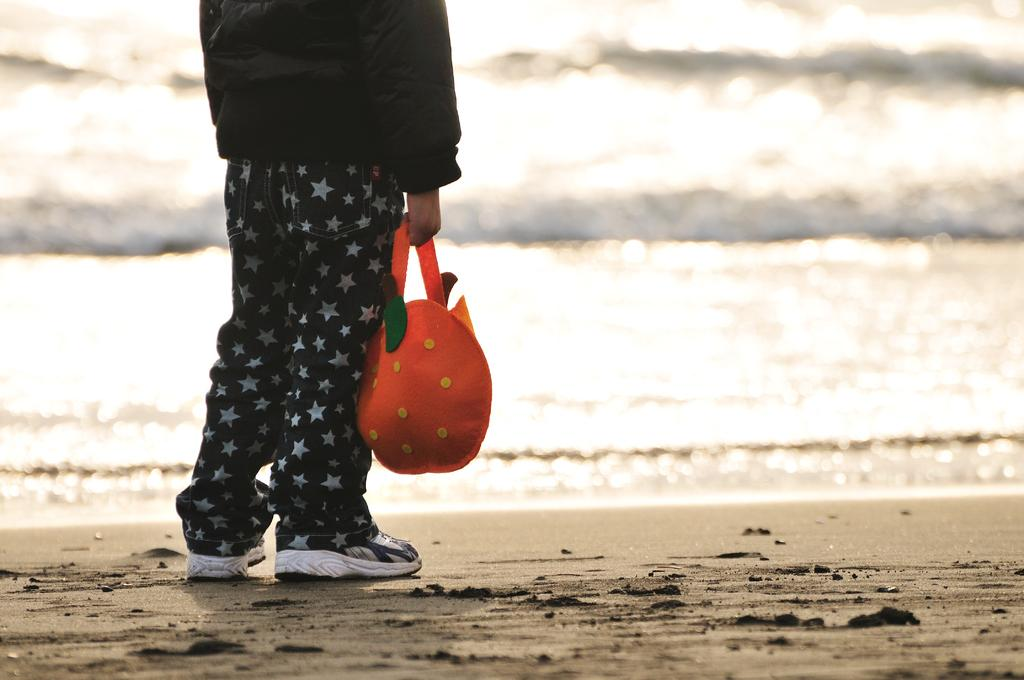What is present in the image? There is a person in the image. What is the person standing on? The person is standing on land. What is the person holding? The person is holding an orange bag. What can be seen in the background of the image? There is water visible in the background of the image. How does the person compare the taste of apples and oranges in the image? There is no indication in the image that the person is comparing the taste of apples and oranges, as they are only holding an orange bag. What type of metal can be seen in the image? There is no metal present in the image; it features a person standing on land, holding an orange bag, and with water visible in the background. 